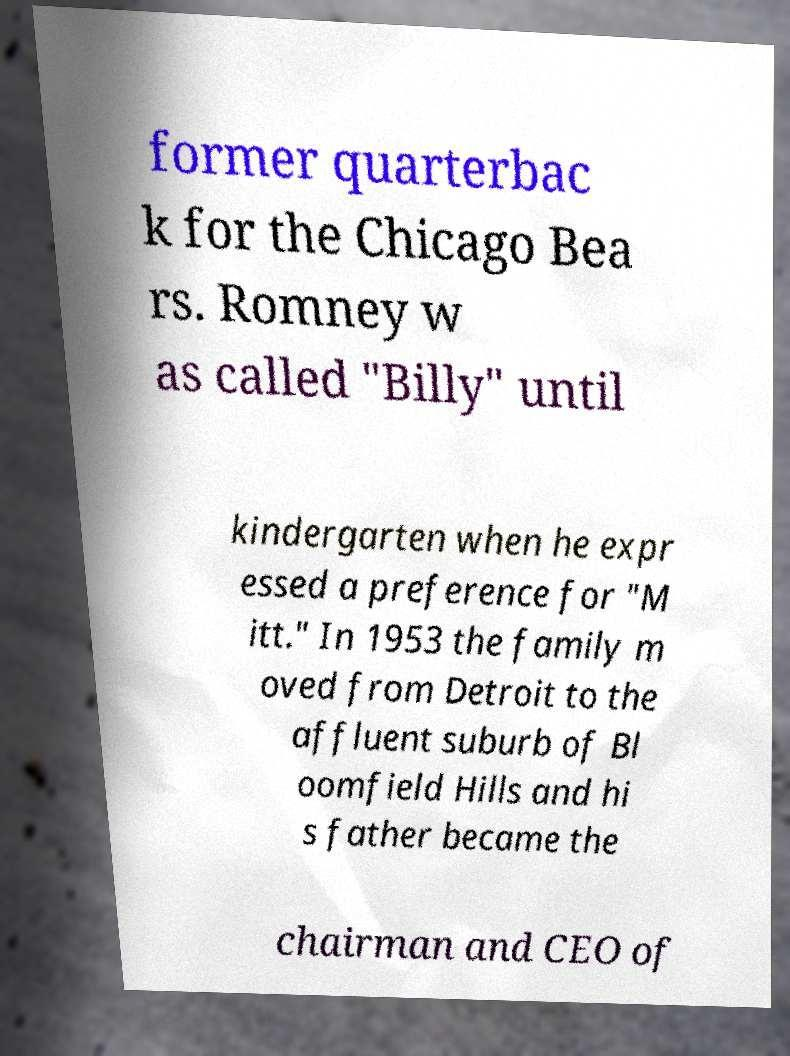Can you read and provide the text displayed in the image?This photo seems to have some interesting text. Can you extract and type it out for me? former quarterbac k for the Chicago Bea rs. Romney w as called "Billy" until kindergarten when he expr essed a preference for "M itt." In 1953 the family m oved from Detroit to the affluent suburb of Bl oomfield Hills and hi s father became the chairman and CEO of 